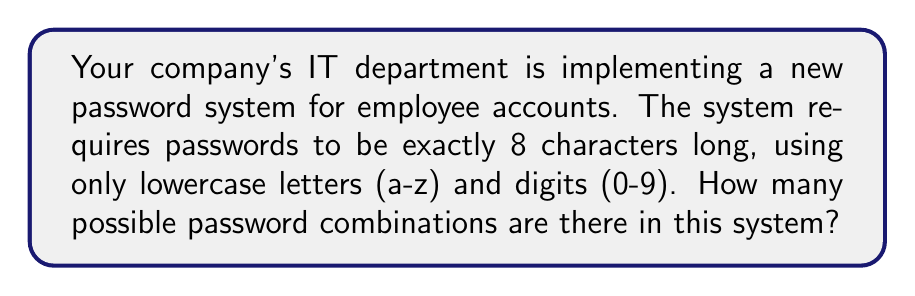Show me your answer to this math problem. Let's break this down step-by-step:

1. First, we need to determine the number of possible characters for each position in the password:
   - There are 26 lowercase letters (a-z)
   - There are 10 digits (0-9)
   - So, in total, there are 26 + 10 = 36 possible characters for each position

2. Now, for each of the 8 positions in the password, we have 36 choices:
   - This is an example of the multiplication principle in combinatorics
   - We multiply the number of choices for each position

3. The total number of possible combinations is:
   $$ 36 \times 36 \times 36 \times 36 \times 36 \times 36 \times 36 \times 36 $$

4. This can be written more concisely as:
   $$ 36^8 $$

5. Calculate the result:
   $$ 36^8 = 2,821,109,907,456 $$

This large number represents the total possible unique passwords in your system, demonstrating the importance of using a combination of letters and numbers in creating secure passwords.
Answer: $2,821,109,907,456$ 